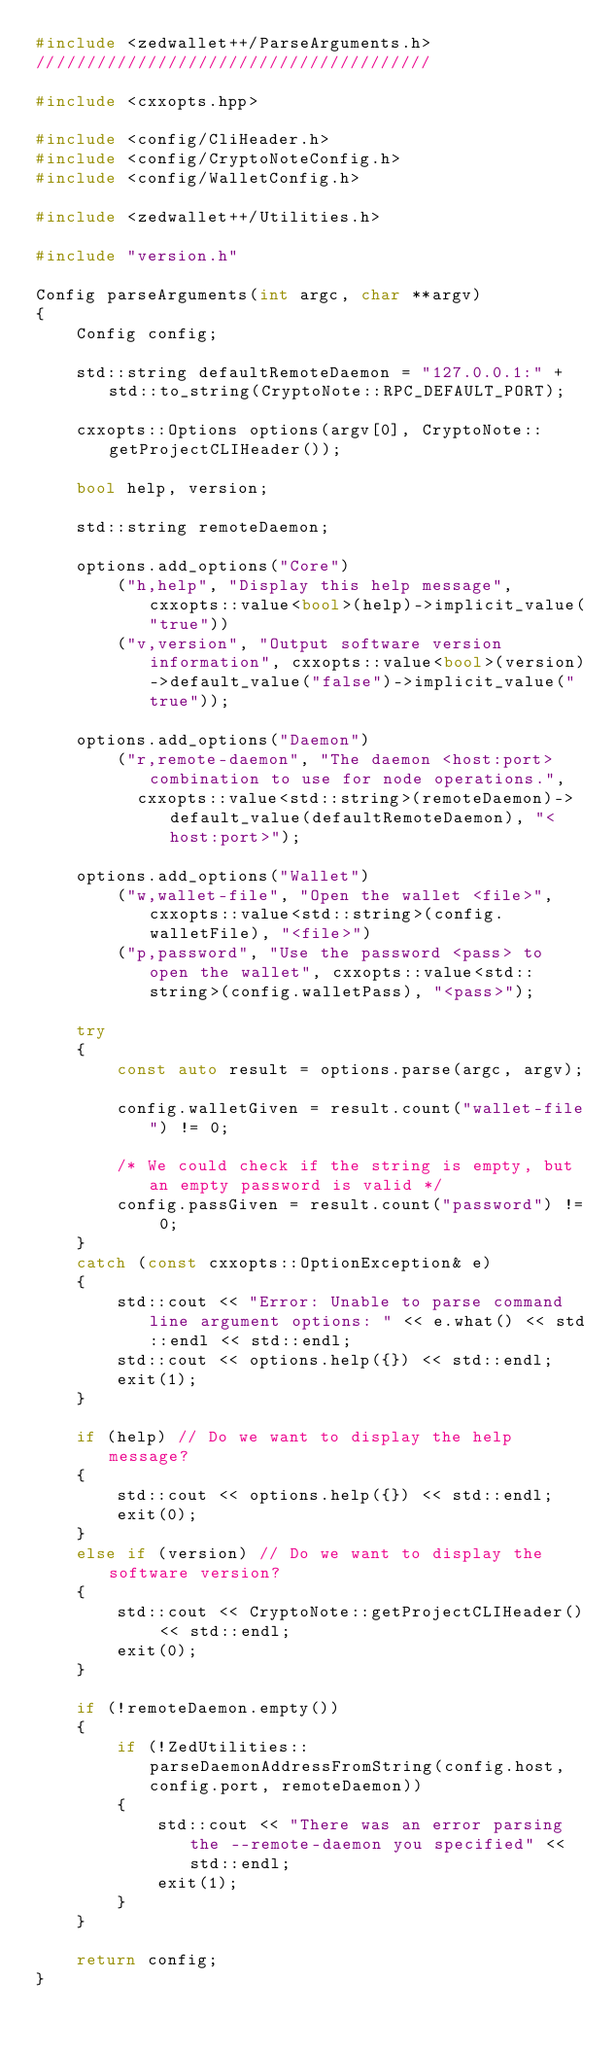Convert code to text. <code><loc_0><loc_0><loc_500><loc_500><_C++_>#include <zedwallet++/ParseArguments.h>
///////////////////////////////////////

#include <cxxopts.hpp>

#include <config/CliHeader.h>
#include <config/CryptoNoteConfig.h>
#include <config/WalletConfig.h>

#include <zedwallet++/Utilities.h>

#include "version.h"

Config parseArguments(int argc, char **argv)
{
    Config config;

    std::string defaultRemoteDaemon = "127.0.0.1:" + std::to_string(CryptoNote::RPC_DEFAULT_PORT);

    cxxopts::Options options(argv[0], CryptoNote::getProjectCLIHeader());

    bool help, version;

    std::string remoteDaemon;

    options.add_options("Core")
        ("h,help", "Display this help message", cxxopts::value<bool>(help)->implicit_value("true"))
        ("v,version", "Output software version information", cxxopts::value<bool>(version)->default_value("false")->implicit_value("true"));

    options.add_options("Daemon")
        ("r,remote-daemon", "The daemon <host:port> combination to use for node operations.",
          cxxopts::value<std::string>(remoteDaemon)->default_value(defaultRemoteDaemon), "<host:port>");

    options.add_options("Wallet")
        ("w,wallet-file", "Open the wallet <file>", cxxopts::value<std::string>(config.walletFile), "<file>")
        ("p,password", "Use the password <pass> to open the wallet", cxxopts::value<std::string>(config.walletPass), "<pass>");

    try
    {
        const auto result = options.parse(argc, argv);

        config.walletGiven = result.count("wallet-file") != 0;

        /* We could check if the string is empty, but an empty password is valid */
        config.passGiven = result.count("password") != 0;
    }
    catch (const cxxopts::OptionException& e)
    {
        std::cout << "Error: Unable to parse command line argument options: " << e.what() << std::endl << std::endl;
        std::cout << options.help({}) << std::endl;
        exit(1);
    }

    if (help) // Do we want to display the help message?
    {
        std::cout << options.help({}) << std::endl;
        exit(0);
    }
    else if (version) // Do we want to display the software version?
    {
        std::cout << CryptoNote::getProjectCLIHeader() << std::endl;
        exit(0);
    }

    if (!remoteDaemon.empty())
    {
        if (!ZedUtilities::parseDaemonAddressFromString(config.host, config.port, remoteDaemon))
        {
            std::cout << "There was an error parsing the --remote-daemon you specified" << std::endl;
            exit(1);
        }
    }

    return config;
}
</code> 